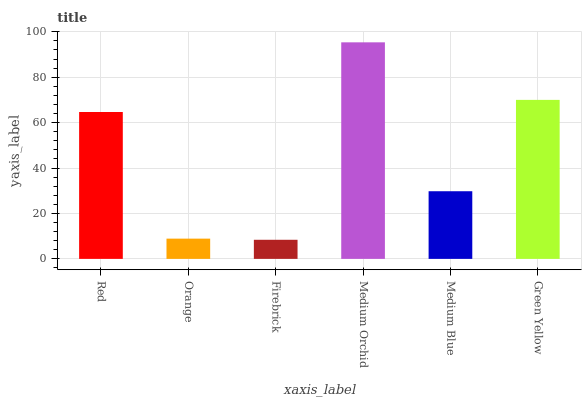Is Firebrick the minimum?
Answer yes or no. Yes. Is Medium Orchid the maximum?
Answer yes or no. Yes. Is Orange the minimum?
Answer yes or no. No. Is Orange the maximum?
Answer yes or no. No. Is Red greater than Orange?
Answer yes or no. Yes. Is Orange less than Red?
Answer yes or no. Yes. Is Orange greater than Red?
Answer yes or no. No. Is Red less than Orange?
Answer yes or no. No. Is Red the high median?
Answer yes or no. Yes. Is Medium Blue the low median?
Answer yes or no. Yes. Is Orange the high median?
Answer yes or no. No. Is Orange the low median?
Answer yes or no. No. 